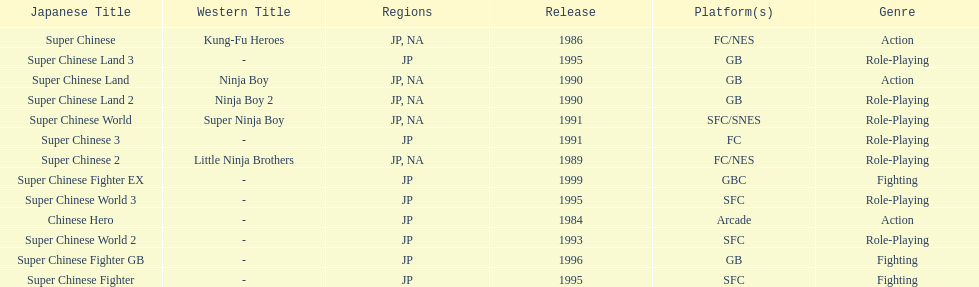Number of super chinese world games released 3. 